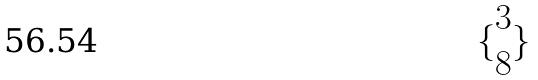<formula> <loc_0><loc_0><loc_500><loc_500>\{ \begin{matrix} 3 \\ 8 \end{matrix} \}</formula> 